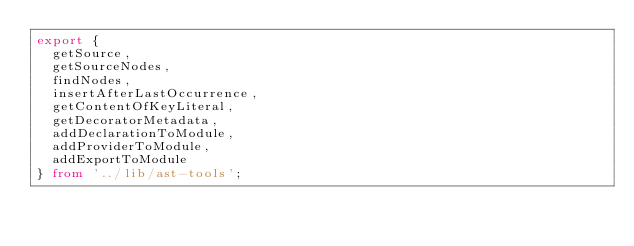<code> <loc_0><loc_0><loc_500><loc_500><_TypeScript_>export {
  getSource,
  getSourceNodes,
  findNodes,
  insertAfterLastOccurrence,
  getContentOfKeyLiteral,
  getDecoratorMetadata,
  addDeclarationToModule,
  addProviderToModule,
  addExportToModule
} from '../lib/ast-tools';
</code> 